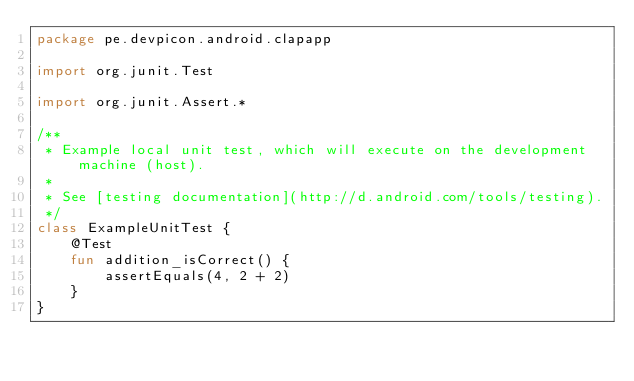<code> <loc_0><loc_0><loc_500><loc_500><_Kotlin_>package pe.devpicon.android.clapapp

import org.junit.Test

import org.junit.Assert.*

/**
 * Example local unit test, which will execute on the development machine (host).
 *
 * See [testing documentation](http://d.android.com/tools/testing).
 */
class ExampleUnitTest {
    @Test
    fun addition_isCorrect() {
        assertEquals(4, 2 + 2)
    }
}
</code> 